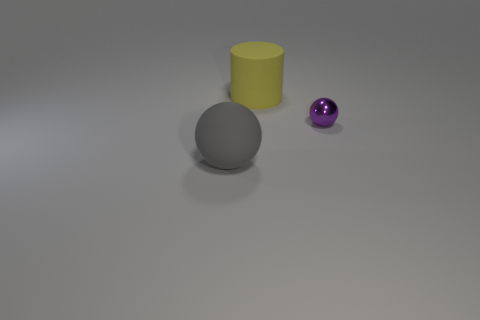There is a object that is on the right side of the gray ball and to the left of the shiny object; what is its size?
Provide a succinct answer. Large. Are there any purple shiny balls to the right of the big rubber ball?
Offer a terse response. Yes. What number of objects are either big rubber objects behind the tiny metallic object or large cylinders?
Your answer should be very brief. 1. There is a sphere on the left side of the big matte cylinder; how many rubber objects are in front of it?
Offer a very short reply. 0. Is the number of large yellow cylinders right of the cylinder less than the number of large cylinders right of the metallic thing?
Your answer should be very brief. No. The thing behind the ball that is behind the gray sphere is what shape?
Offer a terse response. Cylinder. How many other things are the same material as the purple object?
Offer a terse response. 0. Is there anything else that is the same size as the yellow rubber cylinder?
Your response must be concise. Yes. Is the number of small blue cubes greater than the number of big yellow rubber objects?
Make the answer very short. No. What is the size of the purple metallic sphere that is right of the yellow cylinder behind the sphere that is behind the gray matte ball?
Offer a terse response. Small. 